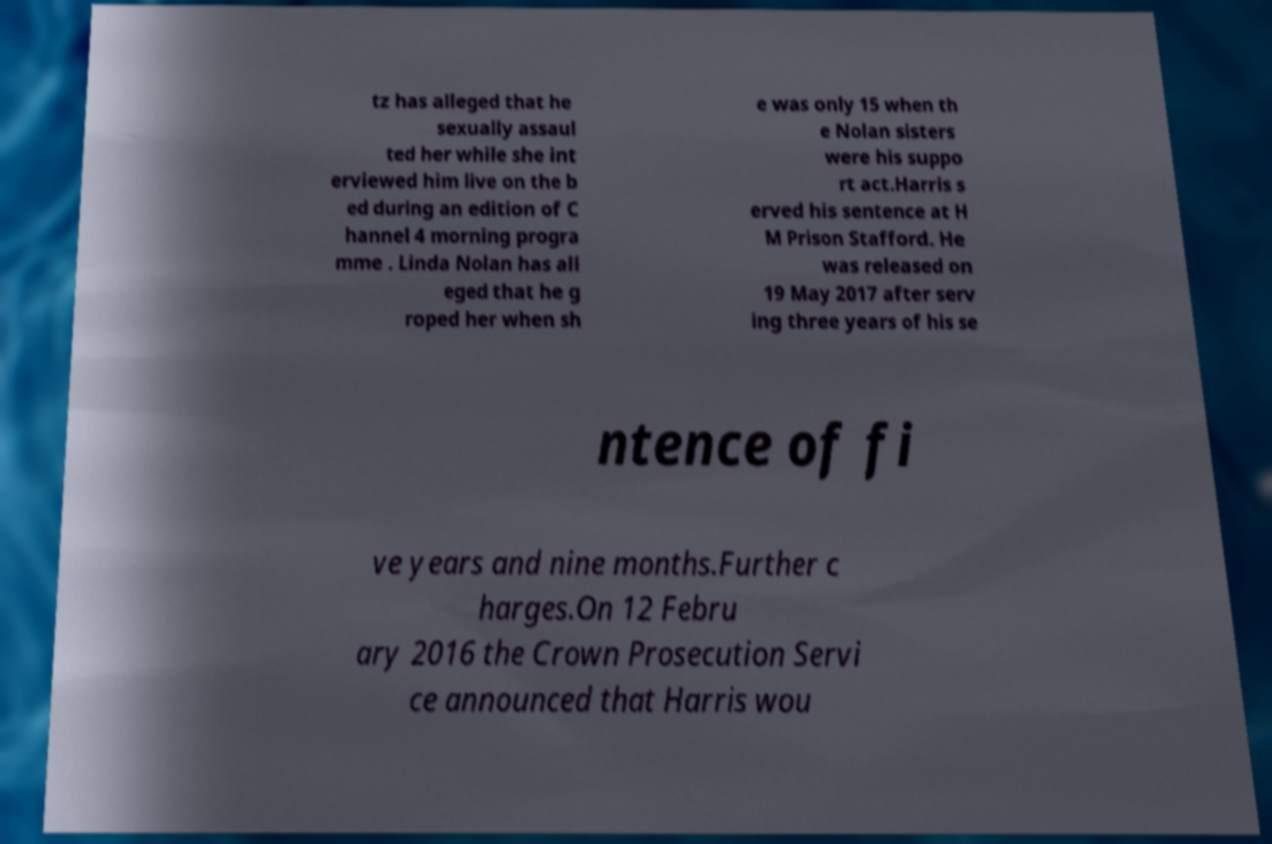There's text embedded in this image that I need extracted. Can you transcribe it verbatim? tz has alleged that he sexually assaul ted her while she int erviewed him live on the b ed during an edition of C hannel 4 morning progra mme . Linda Nolan has all eged that he g roped her when sh e was only 15 when th e Nolan sisters were his suppo rt act.Harris s erved his sentence at H M Prison Stafford. He was released on 19 May 2017 after serv ing three years of his se ntence of fi ve years and nine months.Further c harges.On 12 Febru ary 2016 the Crown Prosecution Servi ce announced that Harris wou 